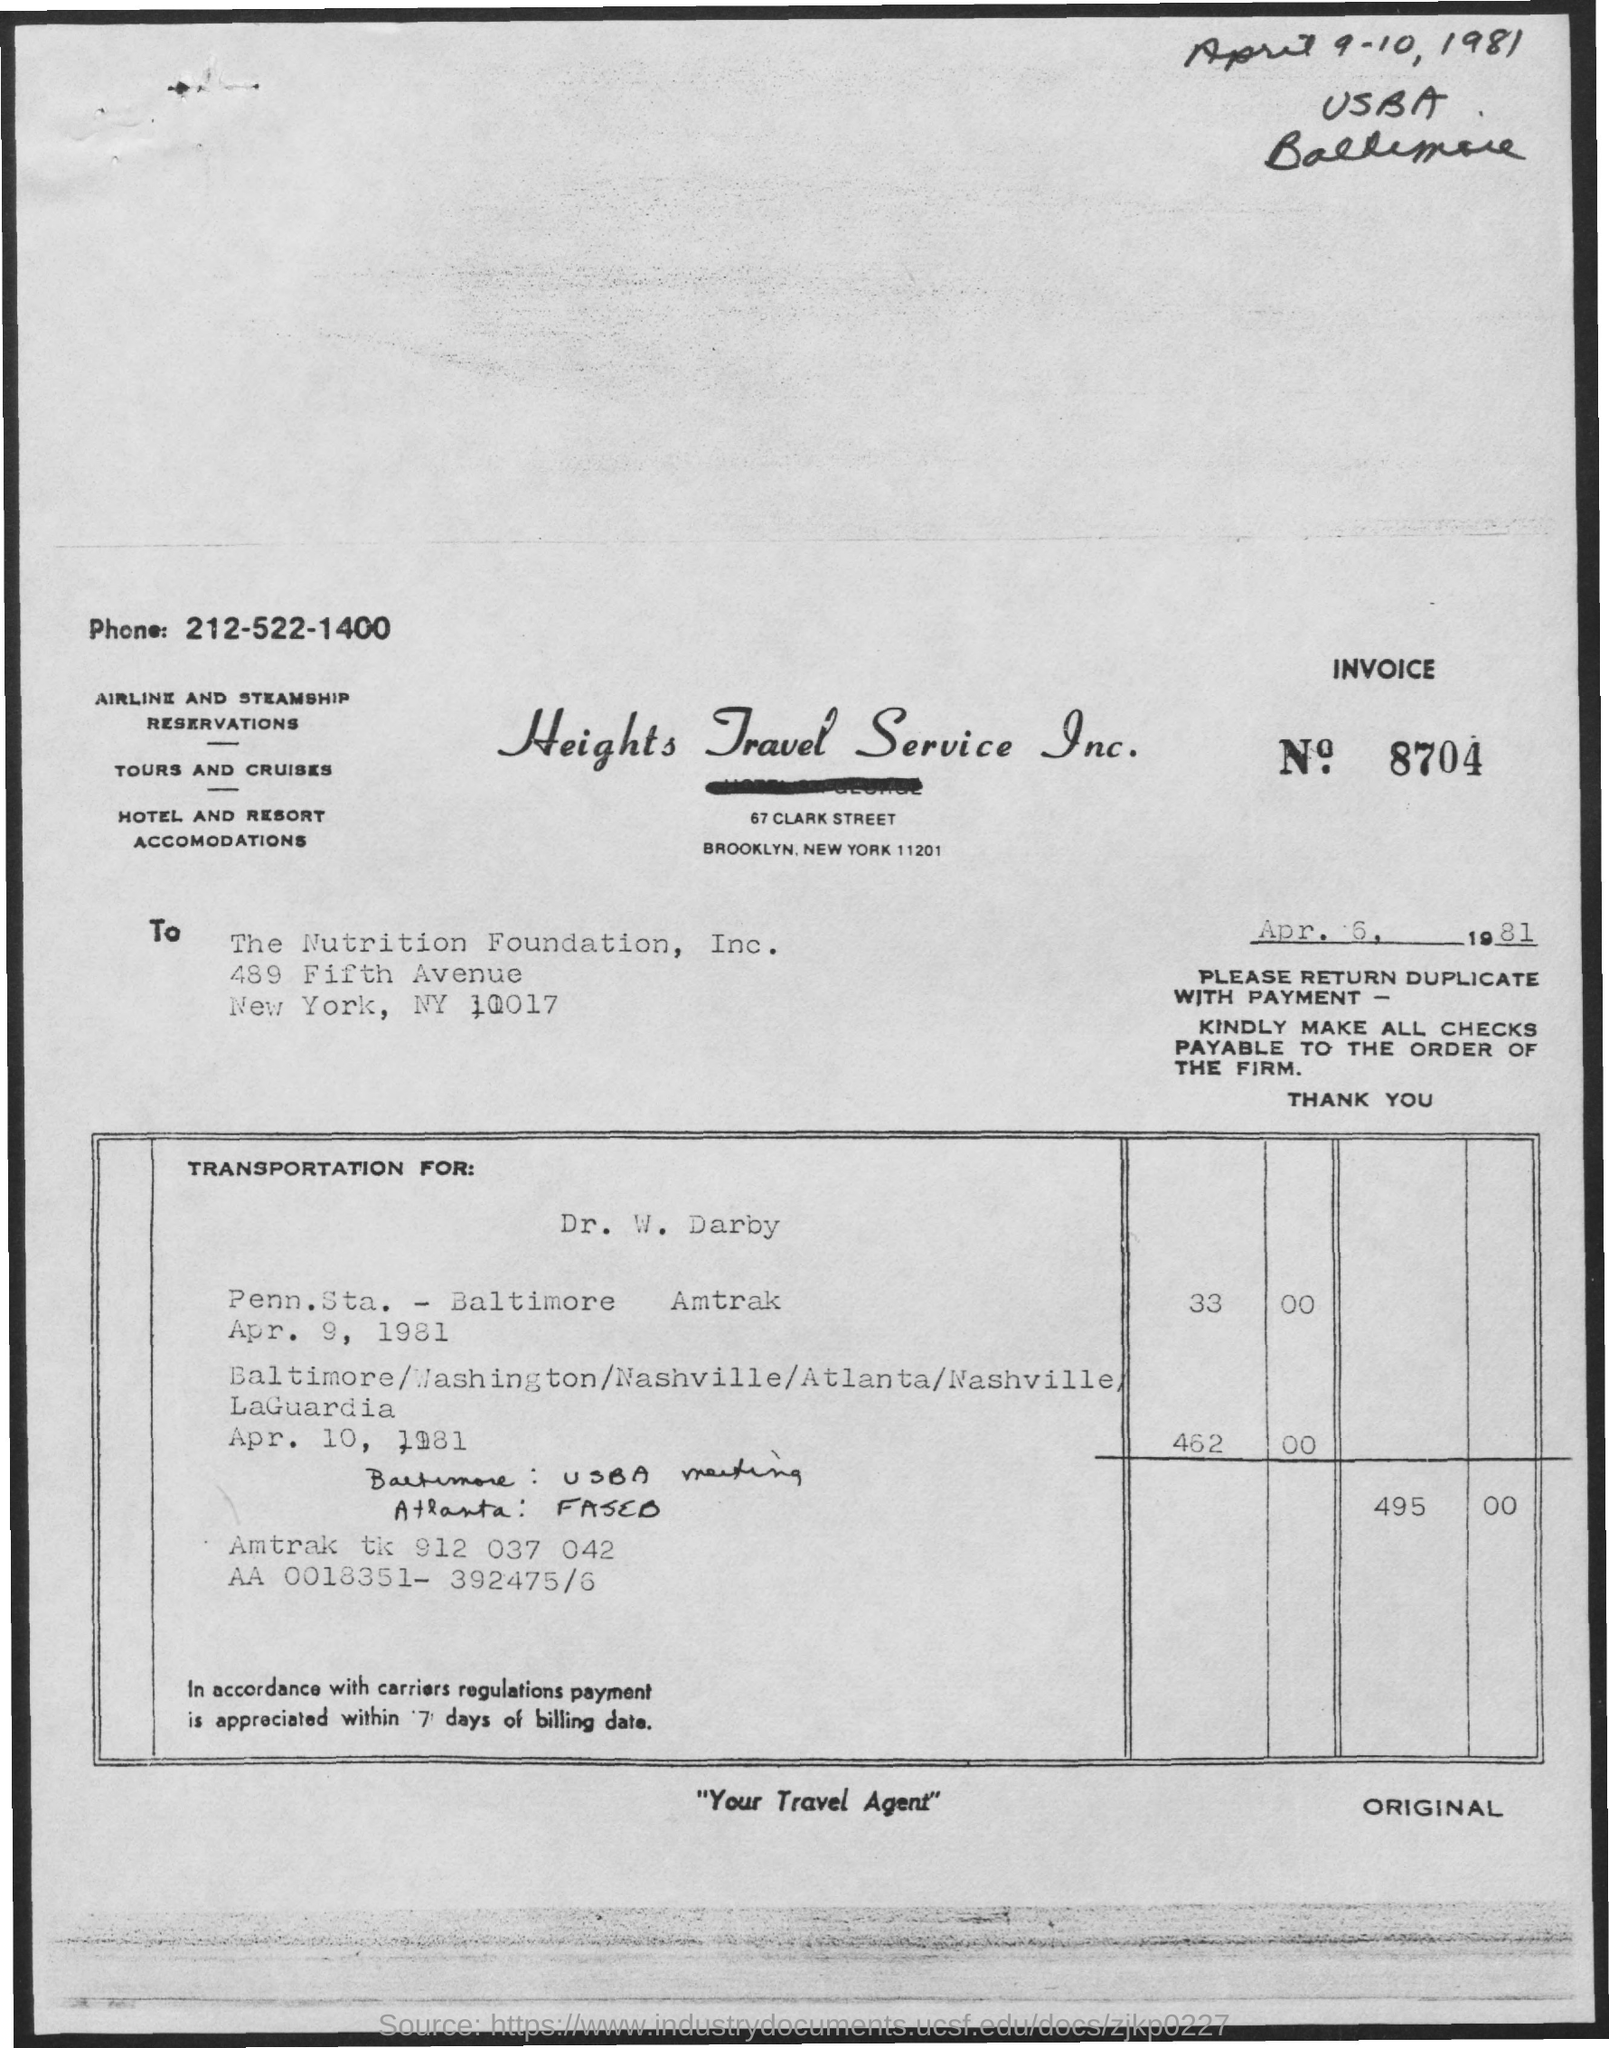Give some essential details in this illustration. I am not sure what you mean by "INVOICE number." Could you provide more context or clarify your question? Heights Travel Service Inc. is the name of the company. The memorandum is addressed to The Nutrition Foundation, Inc. The telephone number is 212-522-1400. 